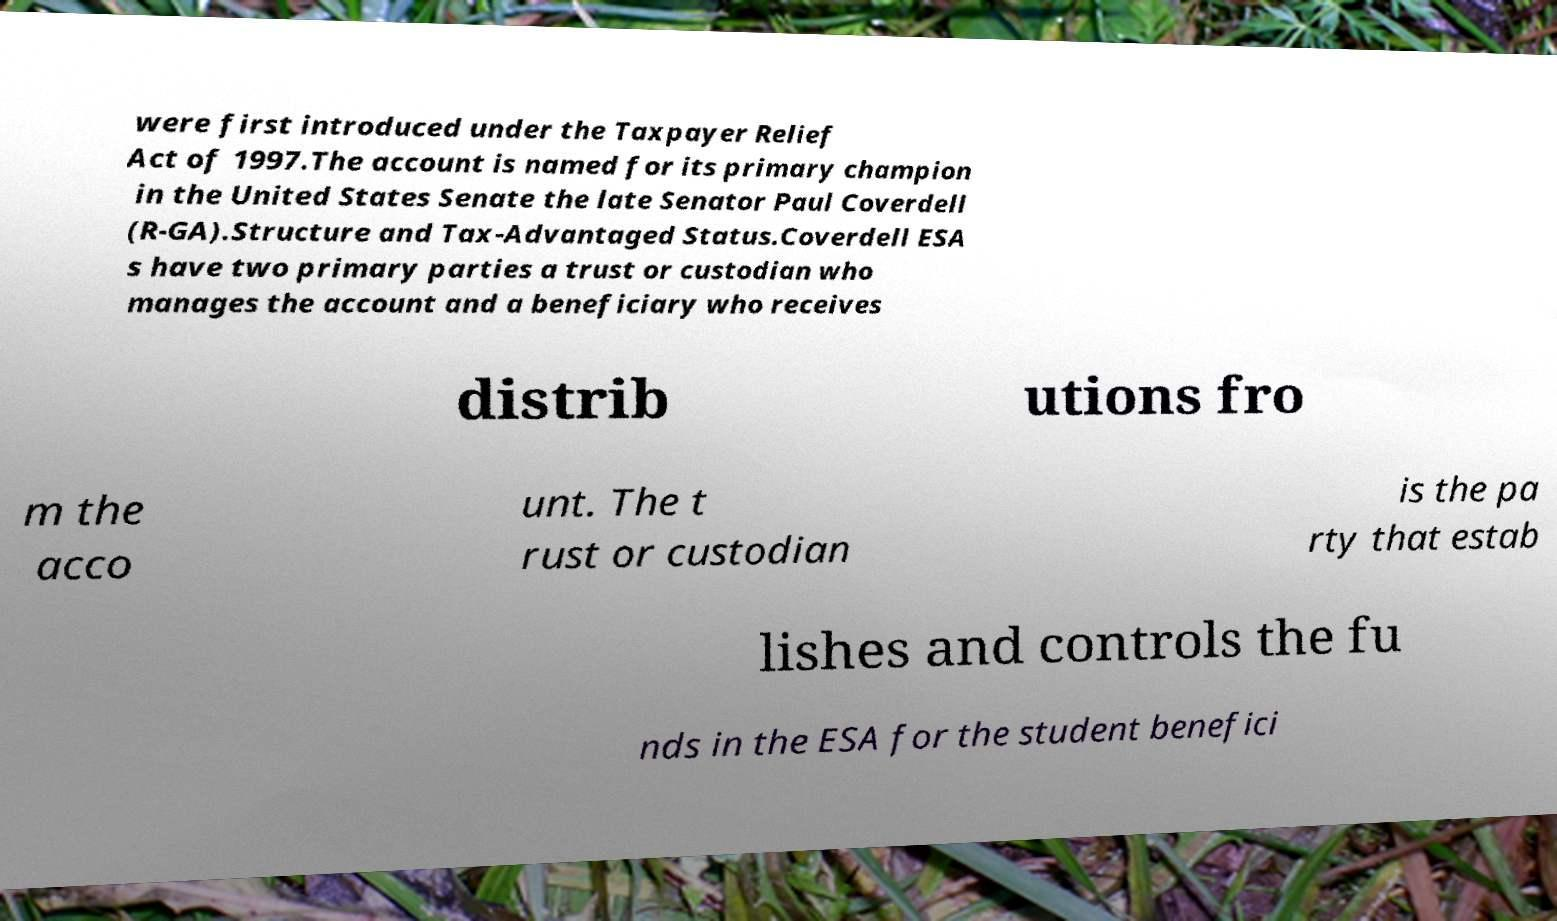Could you extract and type out the text from this image? were first introduced under the Taxpayer Relief Act of 1997.The account is named for its primary champion in the United States Senate the late Senator Paul Coverdell (R-GA).Structure and Tax-Advantaged Status.Coverdell ESA s have two primary parties a trust or custodian who manages the account and a beneficiary who receives distrib utions fro m the acco unt. The t rust or custodian is the pa rty that estab lishes and controls the fu nds in the ESA for the student benefici 